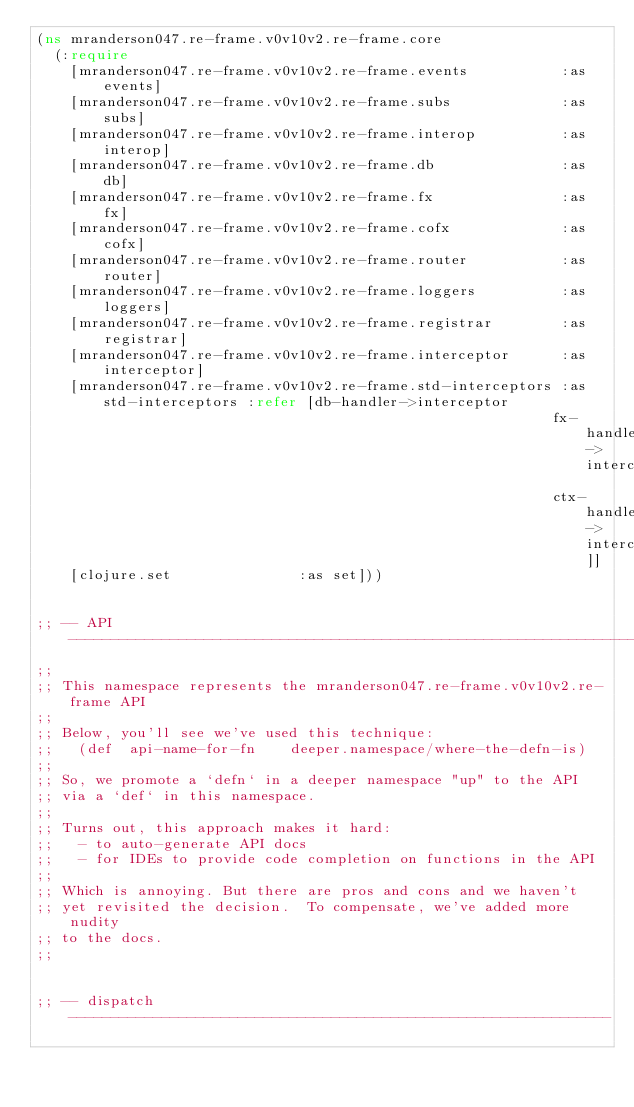Convert code to text. <code><loc_0><loc_0><loc_500><loc_500><_Clojure_>(ns mranderson047.re-frame.v0v10v2.re-frame.core
  (:require
    [mranderson047.re-frame.v0v10v2.re-frame.events           :as events]
    [mranderson047.re-frame.v0v10v2.re-frame.subs             :as subs]
    [mranderson047.re-frame.v0v10v2.re-frame.interop          :as interop]
    [mranderson047.re-frame.v0v10v2.re-frame.db               :as db]
    [mranderson047.re-frame.v0v10v2.re-frame.fx               :as fx]
    [mranderson047.re-frame.v0v10v2.re-frame.cofx             :as cofx]
    [mranderson047.re-frame.v0v10v2.re-frame.router           :as router]
    [mranderson047.re-frame.v0v10v2.re-frame.loggers          :as loggers]
    [mranderson047.re-frame.v0v10v2.re-frame.registrar        :as registrar]
    [mranderson047.re-frame.v0v10v2.re-frame.interceptor      :as interceptor]
    [mranderson047.re-frame.v0v10v2.re-frame.std-interceptors :as std-interceptors :refer [db-handler->interceptor
                                                             fx-handler->interceptor
                                                             ctx-handler->interceptor]]
    [clojure.set               :as set]))


;; -- API ---------------------------------------------------------------------
;;
;; This namespace represents the mranderson047.re-frame.v0v10v2.re-frame API
;;
;; Below, you'll see we've used this technique:
;;   (def  api-name-for-fn    deeper.namespace/where-the-defn-is)
;;
;; So, we promote a `defn` in a deeper namespace "up" to the API
;; via a `def` in this namespace.
;;
;; Turns out, this approach makes it hard:
;;   - to auto-generate API docs
;;   - for IDEs to provide code completion on functions in the API
;;
;; Which is annoying. But there are pros and cons and we haven't
;; yet revisited the decision.  To compensate, we've added more nudity
;; to the docs.
;;


;; -- dispatch ----------------------------------------------------------------</code> 